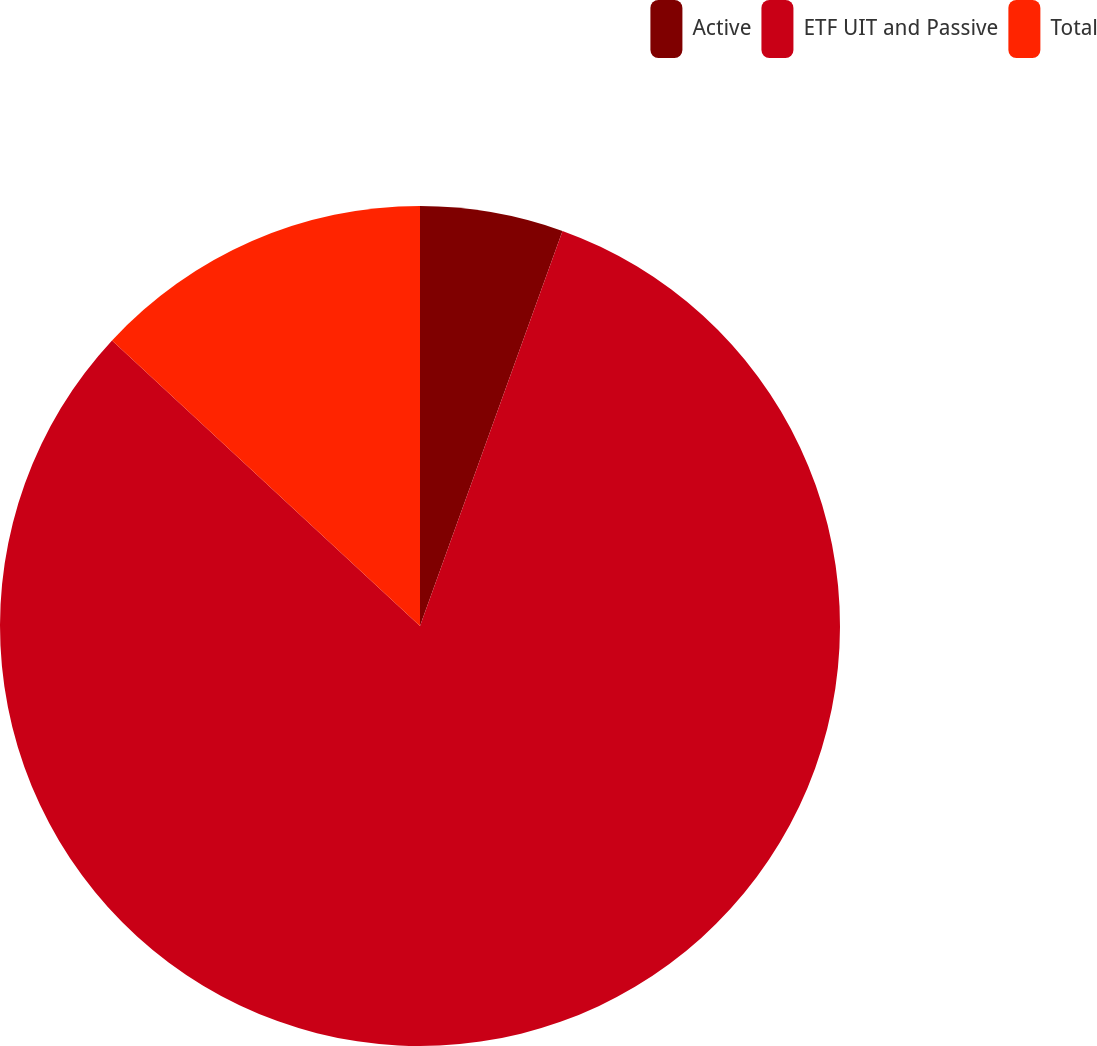Convert chart to OTSL. <chart><loc_0><loc_0><loc_500><loc_500><pie_chart><fcel>Active<fcel>ETF UIT and Passive<fcel>Total<nl><fcel>5.51%<fcel>81.39%<fcel>13.1%<nl></chart> 